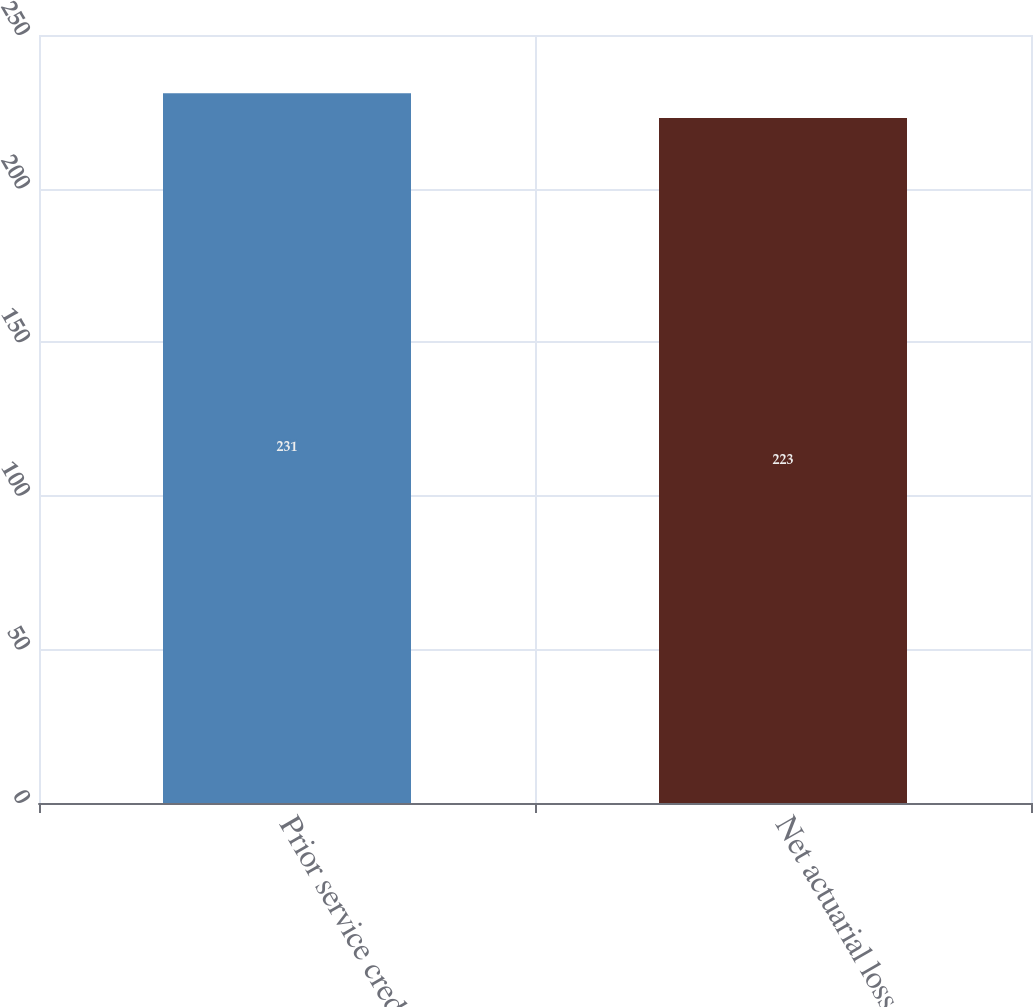<chart> <loc_0><loc_0><loc_500><loc_500><bar_chart><fcel>Prior service credit<fcel>Net actuarial loss<nl><fcel>231<fcel>223<nl></chart> 